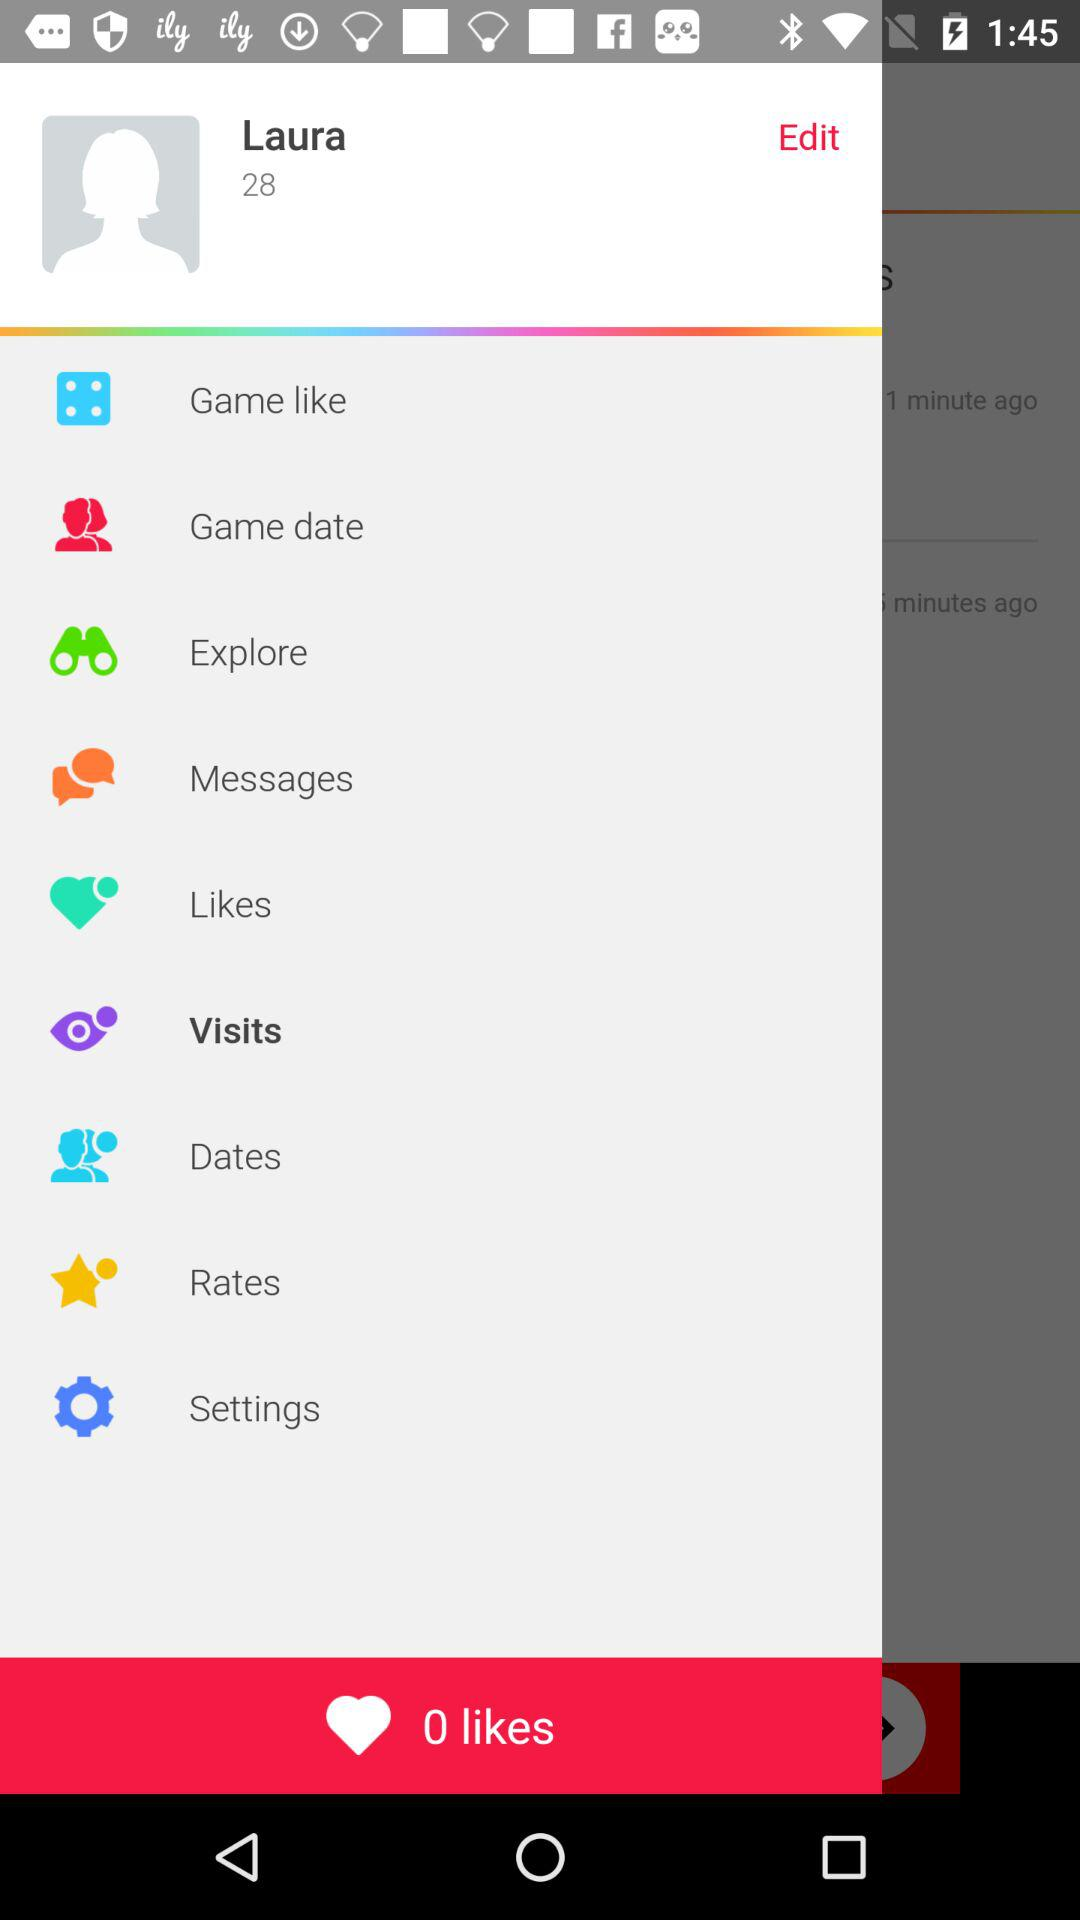What is the name of the user? The name of the user is Laura. 